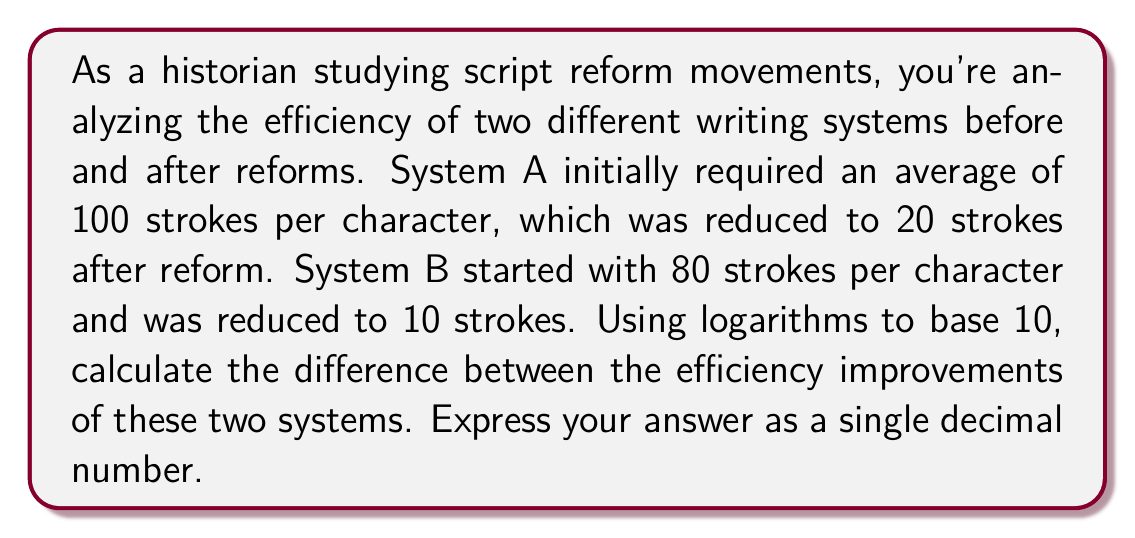Can you solve this math problem? To solve this problem, we'll follow these steps:

1) First, let's define efficiency as the reciprocal of the number of strokes. The more strokes required, the less efficient the system.

2) We'll calculate the efficiency improvement for each system using the formula:
   $\log_{10}(\text{new efficiency}) - \log_{10}(\text{old efficiency})$

3) For System A:
   Old efficiency: $\frac{1}{100}$
   New efficiency: $\frac{1}{20}$
   
   Improvement = $\log_{10}(\frac{1}{20}) - \log_{10}(\frac{1}{100})$
                = $\log_{10}(\frac{100}{20})$
                = $\log_{10}(5)$
                = $0.6990$

4) For System B:
   Old efficiency: $\frac{1}{80}$
   New efficiency: $\frac{1}{10}$
   
   Improvement = $\log_{10}(\frac{1}{10}) - \log_{10}(\frac{1}{80})$
                = $\log_{10}(\frac{80}{10})$
                = $\log_{10}(8)$
                = $0.9031$

5) The difference in improvement:
   $0.9031 - 0.6990 = 0.2041$

Therefore, the difference between the efficiency improvements of the two systems, expressed on a logarithmic scale, is 0.2041.
Answer: 0.2041 